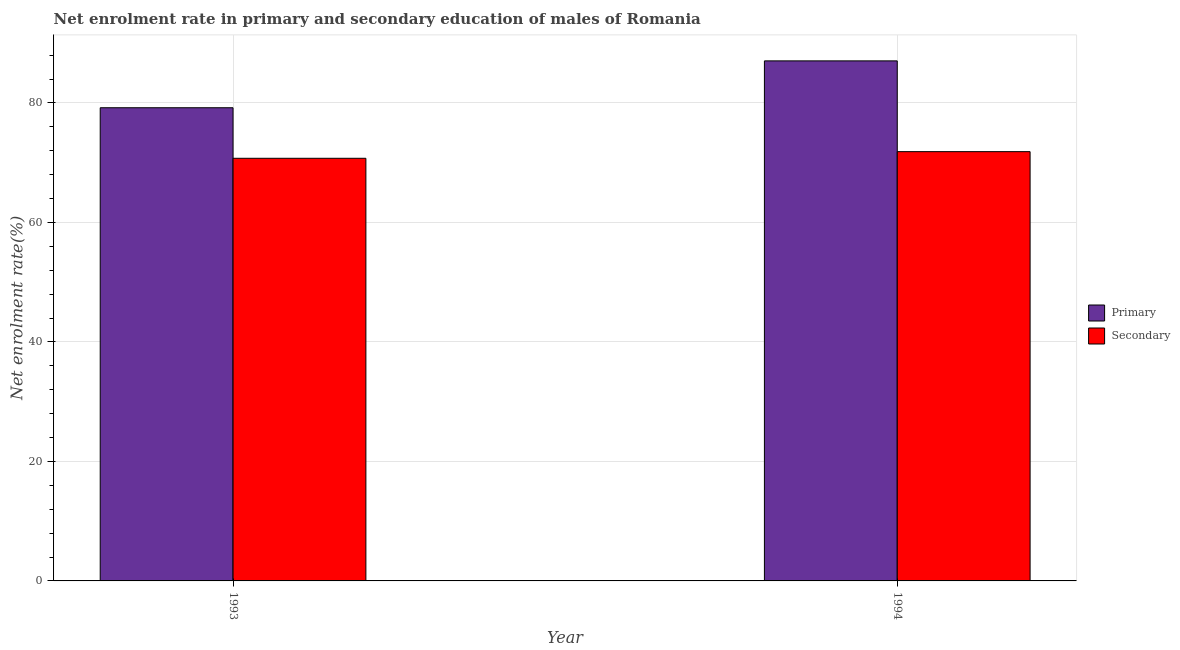How many groups of bars are there?
Offer a very short reply. 2. In how many cases, is the number of bars for a given year not equal to the number of legend labels?
Give a very brief answer. 0. What is the enrollment rate in primary education in 1993?
Your response must be concise. 79.19. Across all years, what is the maximum enrollment rate in primary education?
Make the answer very short. 87.04. Across all years, what is the minimum enrollment rate in primary education?
Ensure brevity in your answer.  79.19. In which year was the enrollment rate in primary education minimum?
Offer a terse response. 1993. What is the total enrollment rate in secondary education in the graph?
Ensure brevity in your answer.  142.58. What is the difference between the enrollment rate in secondary education in 1993 and that in 1994?
Your answer should be very brief. -1.11. What is the difference between the enrollment rate in secondary education in 1994 and the enrollment rate in primary education in 1993?
Your answer should be very brief. 1.11. What is the average enrollment rate in secondary education per year?
Your answer should be very brief. 71.29. In the year 1994, what is the difference between the enrollment rate in secondary education and enrollment rate in primary education?
Offer a very short reply. 0. What is the ratio of the enrollment rate in secondary education in 1993 to that in 1994?
Give a very brief answer. 0.98. Is the enrollment rate in secondary education in 1993 less than that in 1994?
Provide a succinct answer. Yes. What does the 2nd bar from the left in 1993 represents?
Ensure brevity in your answer.  Secondary. What does the 2nd bar from the right in 1994 represents?
Give a very brief answer. Primary. Are all the bars in the graph horizontal?
Your answer should be compact. No. How many years are there in the graph?
Your answer should be very brief. 2. Are the values on the major ticks of Y-axis written in scientific E-notation?
Offer a terse response. No. How many legend labels are there?
Make the answer very short. 2. What is the title of the graph?
Give a very brief answer. Net enrolment rate in primary and secondary education of males of Romania. Does "Revenue" appear as one of the legend labels in the graph?
Give a very brief answer. No. What is the label or title of the X-axis?
Provide a short and direct response. Year. What is the label or title of the Y-axis?
Your response must be concise. Net enrolment rate(%). What is the Net enrolment rate(%) in Primary in 1993?
Offer a very short reply. 79.19. What is the Net enrolment rate(%) in Secondary in 1993?
Provide a short and direct response. 70.73. What is the Net enrolment rate(%) of Primary in 1994?
Give a very brief answer. 87.04. What is the Net enrolment rate(%) in Secondary in 1994?
Give a very brief answer. 71.85. Across all years, what is the maximum Net enrolment rate(%) in Primary?
Offer a very short reply. 87.04. Across all years, what is the maximum Net enrolment rate(%) of Secondary?
Give a very brief answer. 71.85. Across all years, what is the minimum Net enrolment rate(%) of Primary?
Make the answer very short. 79.19. Across all years, what is the minimum Net enrolment rate(%) of Secondary?
Make the answer very short. 70.73. What is the total Net enrolment rate(%) of Primary in the graph?
Offer a terse response. 166.23. What is the total Net enrolment rate(%) of Secondary in the graph?
Offer a terse response. 142.58. What is the difference between the Net enrolment rate(%) of Primary in 1993 and that in 1994?
Offer a terse response. -7.84. What is the difference between the Net enrolment rate(%) in Secondary in 1993 and that in 1994?
Ensure brevity in your answer.  -1.11. What is the difference between the Net enrolment rate(%) of Primary in 1993 and the Net enrolment rate(%) of Secondary in 1994?
Your answer should be very brief. 7.35. What is the average Net enrolment rate(%) in Primary per year?
Make the answer very short. 83.12. What is the average Net enrolment rate(%) in Secondary per year?
Your response must be concise. 71.29. In the year 1993, what is the difference between the Net enrolment rate(%) of Primary and Net enrolment rate(%) of Secondary?
Keep it short and to the point. 8.46. In the year 1994, what is the difference between the Net enrolment rate(%) in Primary and Net enrolment rate(%) in Secondary?
Ensure brevity in your answer.  15.19. What is the ratio of the Net enrolment rate(%) in Primary in 1993 to that in 1994?
Offer a terse response. 0.91. What is the ratio of the Net enrolment rate(%) of Secondary in 1993 to that in 1994?
Provide a succinct answer. 0.98. What is the difference between the highest and the second highest Net enrolment rate(%) of Primary?
Offer a terse response. 7.84. What is the difference between the highest and the lowest Net enrolment rate(%) of Primary?
Make the answer very short. 7.84. What is the difference between the highest and the lowest Net enrolment rate(%) in Secondary?
Your answer should be very brief. 1.11. 